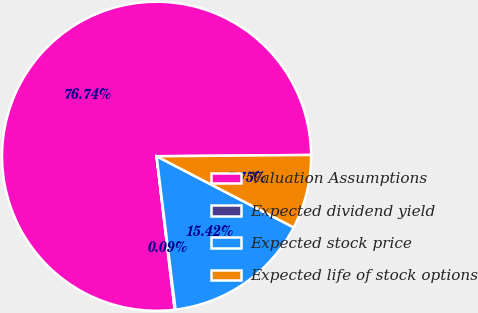Convert chart to OTSL. <chart><loc_0><loc_0><loc_500><loc_500><pie_chart><fcel>Valuation Assumptions<fcel>Expected dividend yield<fcel>Expected stock price<fcel>Expected life of stock options<nl><fcel>76.74%<fcel>0.09%<fcel>15.42%<fcel>7.75%<nl></chart> 